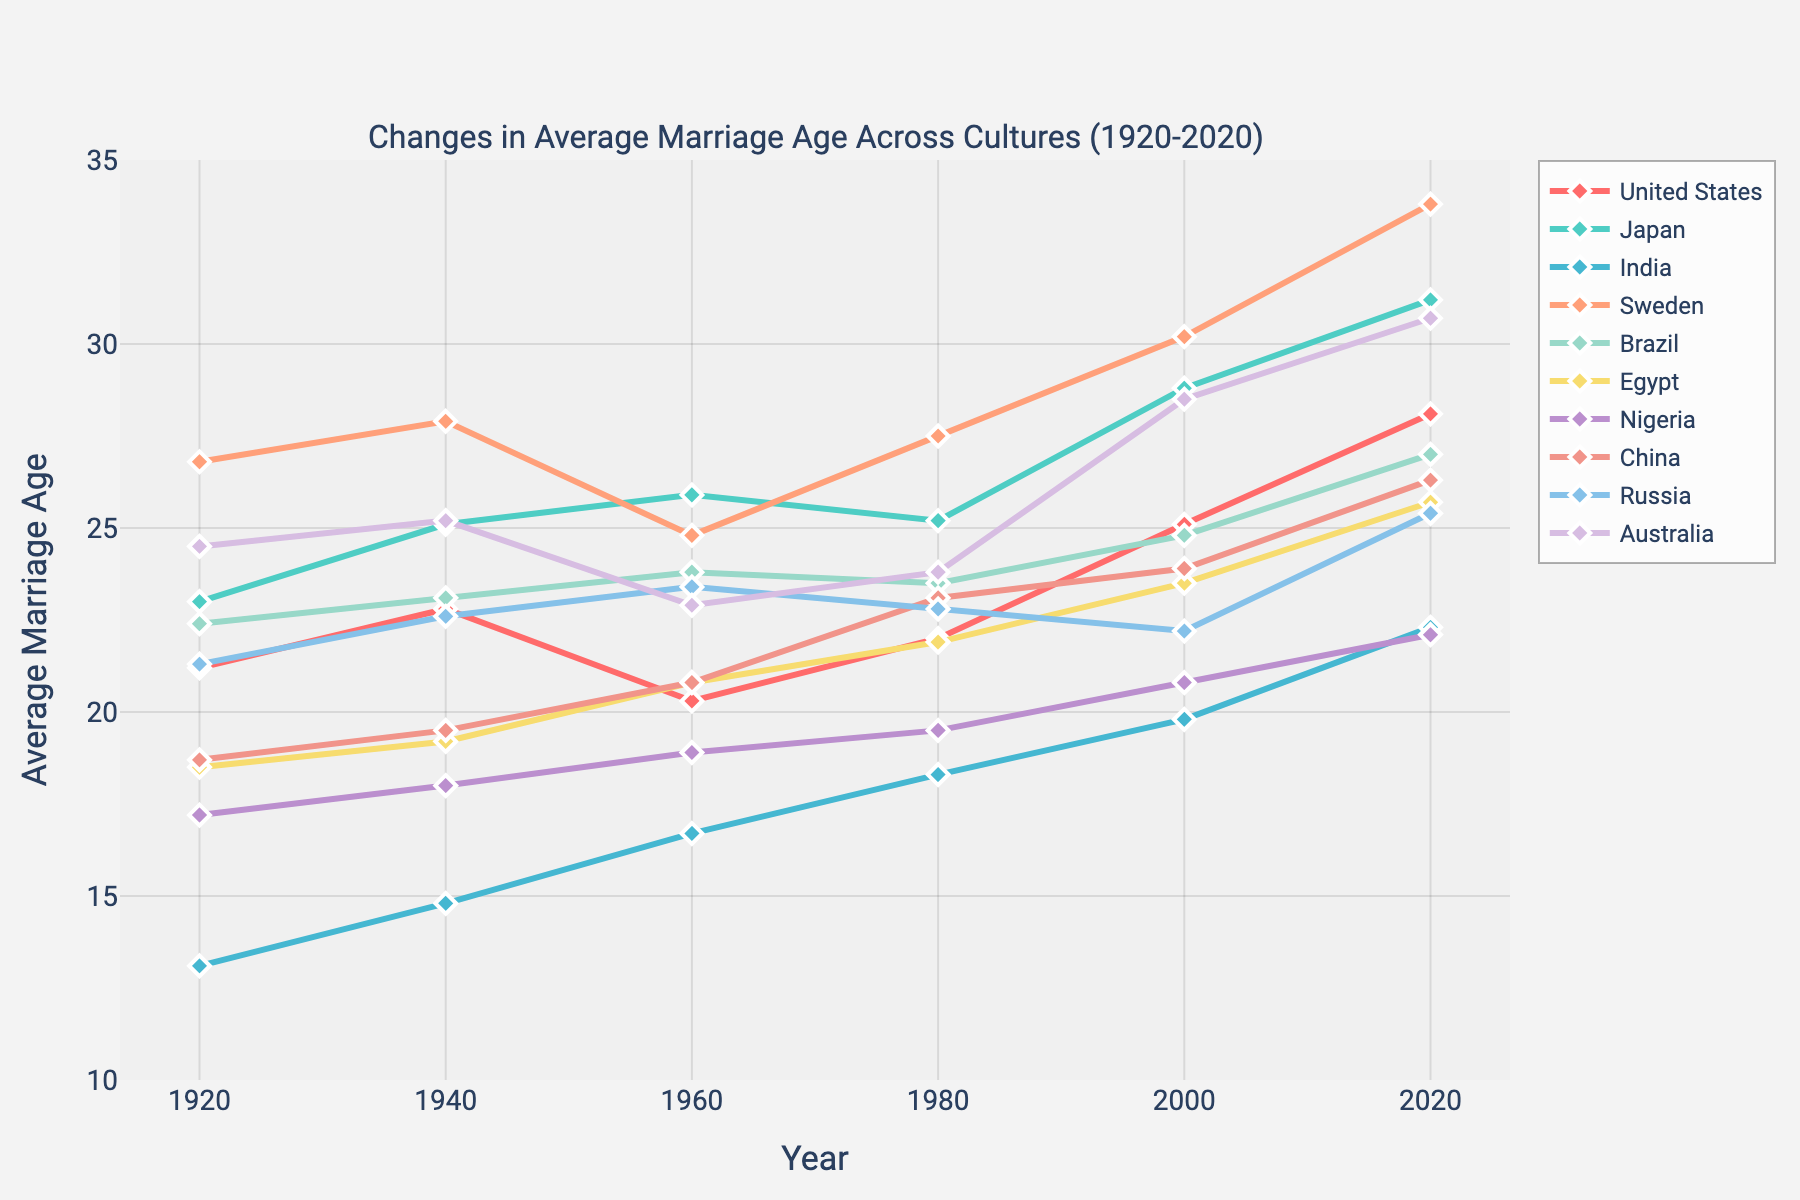What's the average marriage age in the United States in 2020? Locate the line for the United States and identify the point corresponding to the year 2020. The value at this point represents the average marriage age in the United States in 2020.
Answer: 28.1 Which culture had the highest average marriage age in 1920? Analyze the starting points of all the lines on the figure for the year 1920. Compare these values and identify the highest one.
Answer: Sweden By how many years did the average marriage age in Japan increase from 1960 to 2020? Find the points on the Japan line for the years 1960 and 2020. Subtract the 1960 value (25.9) from the 2020 value (31.2). 31.2 - 25.9 = 5.3
Answer: 5.3 Which two cultures had an almost equal average marriage age around 1980? Identify the points on all the lines for the year 1980. Look for two points that are very close in value.
Answer: Russia and Brazil What is the difference between the average marriage age in Egypt and Brazil in 2020? Locate the points for Egypt and Brazil in 2020. Subtract the value of Brazil (27.0) from Egypt (25.7). 27.0 - 25.7 = 1.3
Answer: 1.3 How did the average marriage age in India change from 1920 to 2020? Locate India's line and compare the value at the starting point (1920, 13.1) to the endpoint (2020, 22.3). Notice the increase over time, which represents the change.
Answer: Increased by 9.2 Between which two consecutive decades did the United States see the greatest increase in average marriage age? Compare the vertical distances between successive points on the United States line. Identify the pair of points with the largest vertical difference.
Answer: 1980 to 2000 Which culture had the smallest increase in average marriage age from 1920 to 2020? Calculate the differences between the starting and ending points for all cultures. Identify the culture with the smallest difference.
Answer: Nigeria Compare the average marriage age in 1980 for Australia and Japan. Which was higher and by how much? Locate the points for Australia and Japan in 1980. Compare their values. Subtract Japan (25.2) from Australia (23.8).
Answer: Japan by 1.4 Which culture experienced a decrease in average marriage age between 1940 and 1960? Identify the slopes of the lines between 1940 and 1960. Look for a downward slope (decrease).
Answer: Sweden 